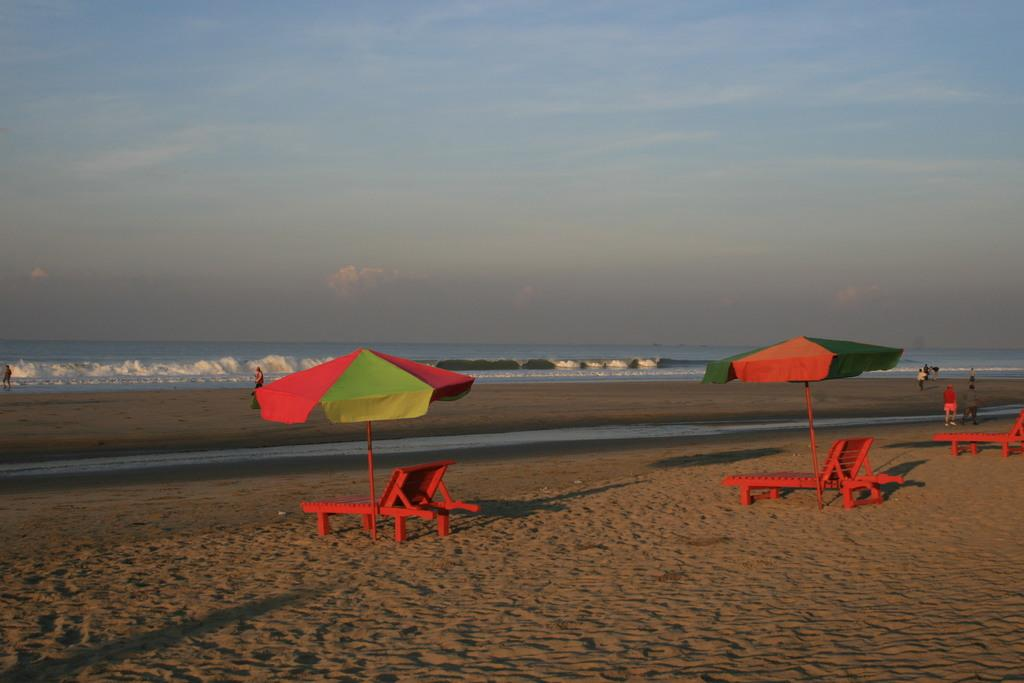What type of location is depicted in the image? There is a beach in the image. What objects are present on the beach for relaxation? Beach beds are present in the image. Are there any people at the beach? Yes, there are people on the beach. What provides shade for the people on the beach? Umbrellas are visible on the beach. What can be seen in the distance behind the beach? There is a sea in the background of the image. What is visible at the top of the image? The sky is visible at the top of the image. How many mice are playing with a feather on the beach in the image? There are no mice or feathers present in the image; it features a beach with people, beach beds, umbrellas, and a sea in the background. 